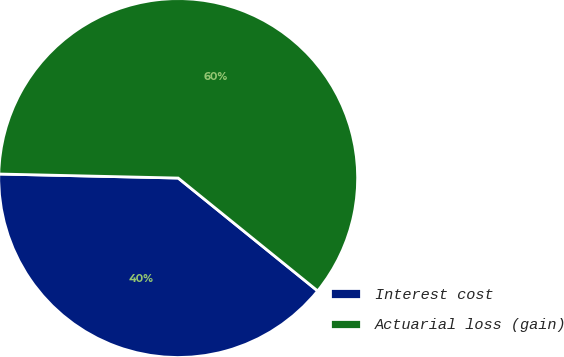Convert chart to OTSL. <chart><loc_0><loc_0><loc_500><loc_500><pie_chart><fcel>Interest cost<fcel>Actuarial loss (gain)<nl><fcel>39.53%<fcel>60.47%<nl></chart> 